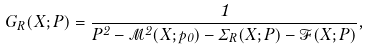<formula> <loc_0><loc_0><loc_500><loc_500>G _ { R } ( X ; P ) = \frac { 1 } { P ^ { 2 } - \mathcal { M } ^ { 2 } ( X ; p _ { 0 } ) - \Sigma _ { R } ( X ; P ) - \mathcal { F } ( X ; P ) } ,</formula> 